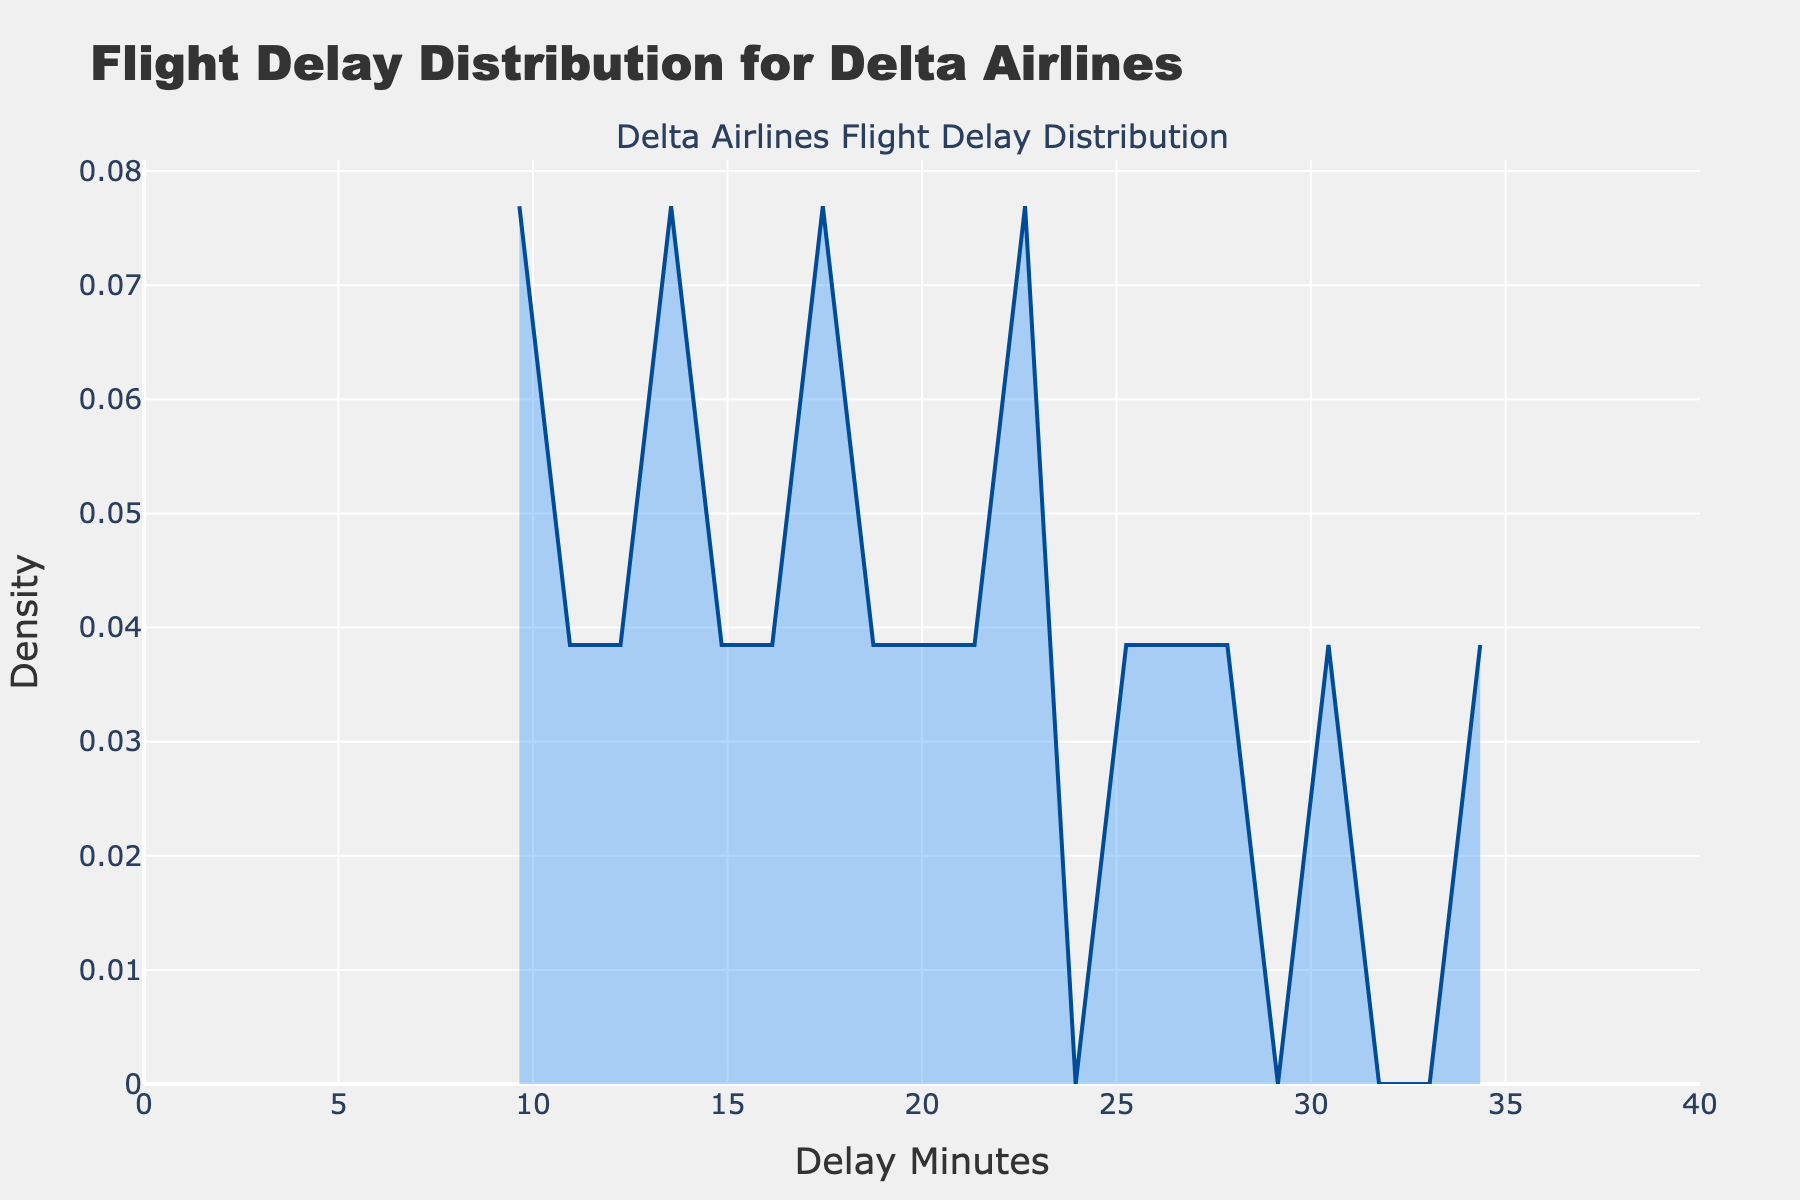What is the title of the plot? The title of the plot is usually placed at the top of the figure, which provides a brief description of what the plot represents.
Answer: Flight Delay Distribution for Delta Airlines What does the x-axis represent? The x-axis usually labels the variable represented horizontally in a plot. In this case, it is labeled "Delay Minutes," indicating the number of minutes flights have been delayed.
Answer: Delay Minutes What does the y-axis represent? The y-axis usually labels the variable represented vertically in a plot. In this case, it is labeled "Density," indicating the density of flight delay times across different airports.
Answer: Density What is the maximum delay time shown on the x-axis? To find the maximum delay time, look at the upper limit of the x-axis range. In the plot, this value would be the highest number on the x-axis.
Answer: 40 At which delay minute does the density peak occur? To determine the peak, locate the highest point on the density line. The x-axis value at this point represents the delay minute with the highest density.
Answer: 16 How does the density change as delay time increases from 10 to 20 minutes? Observe the slope and overall trend of the density line between 10 and 20 delay minutes. Describe whether the density increases, decreases, or stays constant.
Answer: It increases initially and then starts to decrease What is the estimated delay time if you want to see where most delays cluster? Look for the region where the density is highest, indicating where most of the delay times are clustered. The delay minute corresponding to this peak region represents the most common delay time.
Answer: Around 16-18 minutes Which delay minute has the lowest density value between 0 and 40 minutes? Scan the density line for the lowest point between 0 and 40 minutes on the x-axis. The x-axis value at this point represents the delay minute with the lowest density.
Answer: Around 33 minutes How would you describe the skewness of the delay time distribution? Analyze the shape of the density plot. If the longer tail is on the right of the peak, it is right-skewed. If the longer tail is on the left, it is left-skewed. If symmetrical, it is normally distributed.
Answer: Slightly right-skewed 